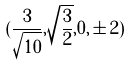Convert formula to latex. <formula><loc_0><loc_0><loc_500><loc_500>( \frac { 3 } { \sqrt { 1 0 } } , \sqrt { \frac { 3 } { 2 } } , 0 , \pm 2 )</formula> 